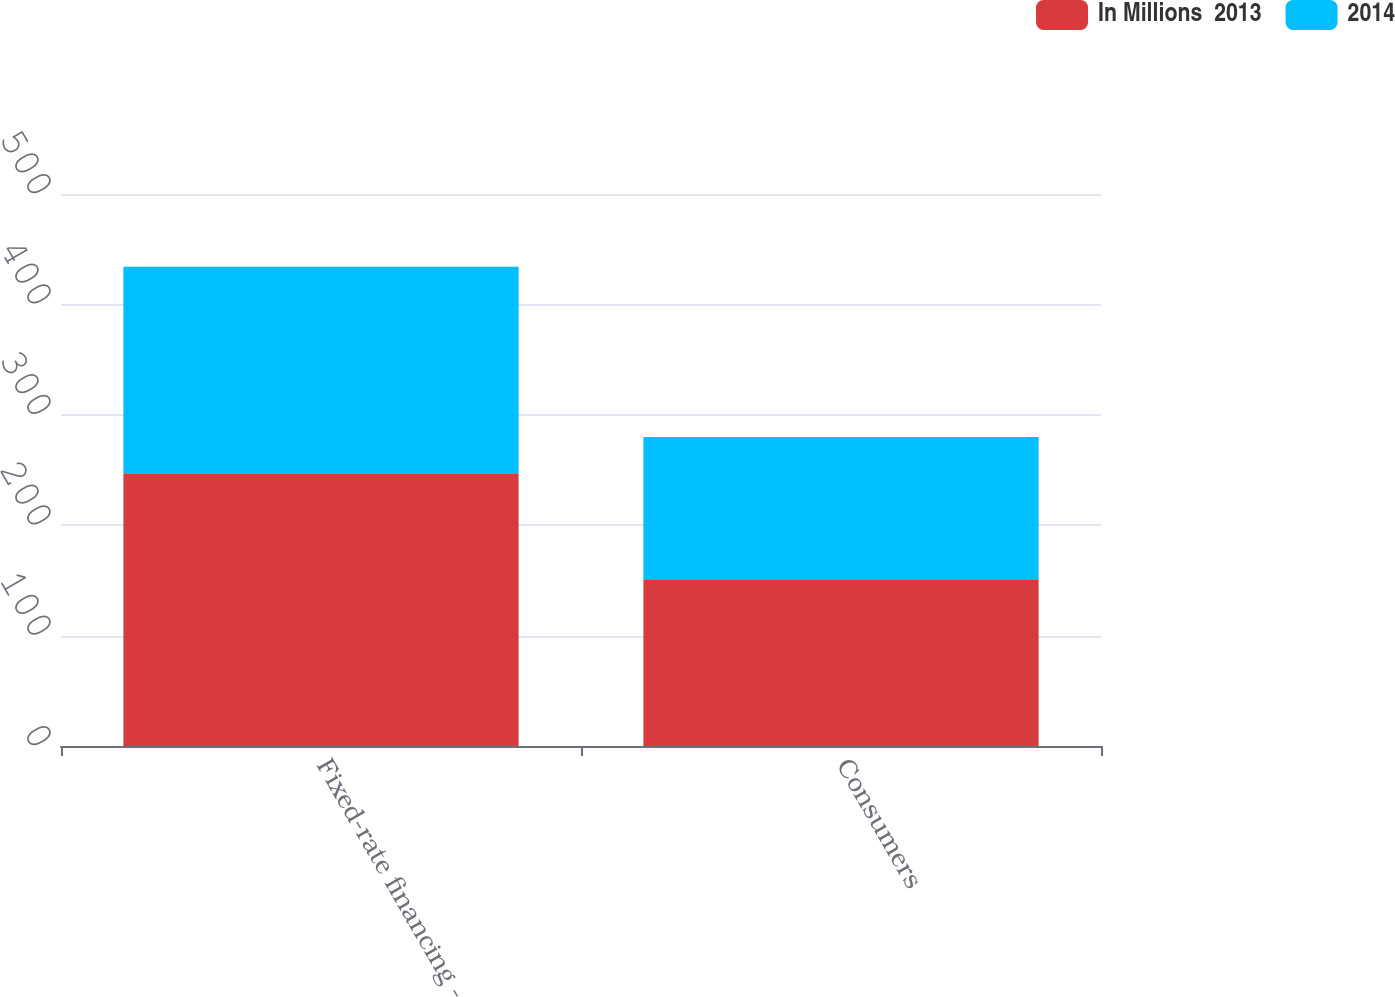<chart> <loc_0><loc_0><loc_500><loc_500><stacked_bar_chart><ecel><fcel>Fixed-rate financing -<fcel>Consumers<nl><fcel>In Millions  2013<fcel>247<fcel>151<nl><fcel>2014<fcel>187<fcel>129<nl></chart> 